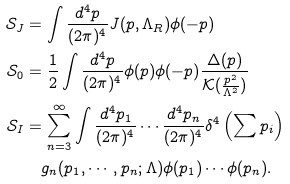<formula> <loc_0><loc_0><loc_500><loc_500>\mathcal { S } _ { J } & = \int \frac { d ^ { 4 } p } { ( 2 \pi ) ^ { 4 } } J ( p , \Lambda _ { R } ) \phi ( - p ) \\ \mathcal { S } _ { 0 } & = \frac { 1 } { 2 } \int \frac { d ^ { 4 } p } { ( 2 \pi ) ^ { 4 } } \phi ( p ) \phi ( - p ) \frac { \Delta ( p ) } { \mathcal { K } ( \frac { p ^ { 2 } } { \Lambda ^ { 2 } } ) } \\ \mathcal { S } _ { I } & = \sum _ { n = 3 } ^ { \infty } \int \frac { d ^ { 4 } p _ { 1 } } { ( 2 \pi ) ^ { 4 } } \cdots \frac { d ^ { 4 } p _ { n } } { ( 2 \pi ) ^ { 4 } } \delta ^ { 4 } \left ( \sum p _ { i } \right ) \\ & \quad g _ { n } ( p _ { 1 } , \cdots , p _ { n } ; \Lambda ) \phi ( p _ { 1 } ) \cdots \phi ( p _ { n } ) . \\</formula> 